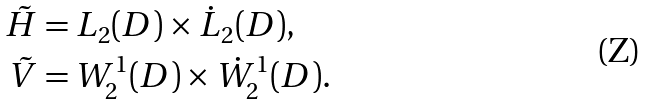<formula> <loc_0><loc_0><loc_500><loc_500>\tilde { H } & = L _ { 2 } ( D ) \times \dot { L } _ { 2 } ( D ) , \\ \tilde { V } & = W _ { 2 } ^ { 1 } ( D ) \times \dot { W } _ { 2 } ^ { 1 } ( D ) .</formula> 